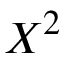Convert formula to latex. <formula><loc_0><loc_0><loc_500><loc_500>X ^ { 2 }</formula> 